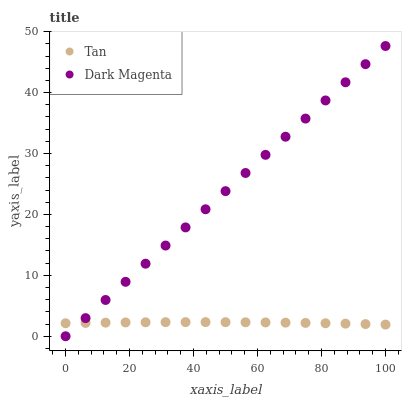Does Tan have the minimum area under the curve?
Answer yes or no. Yes. Does Dark Magenta have the maximum area under the curve?
Answer yes or no. Yes. Does Dark Magenta have the minimum area under the curve?
Answer yes or no. No. Is Dark Magenta the smoothest?
Answer yes or no. Yes. Is Tan the roughest?
Answer yes or no. Yes. Is Dark Magenta the roughest?
Answer yes or no. No. Does Dark Magenta have the lowest value?
Answer yes or no. Yes. Does Dark Magenta have the highest value?
Answer yes or no. Yes. Does Tan intersect Dark Magenta?
Answer yes or no. Yes. Is Tan less than Dark Magenta?
Answer yes or no. No. Is Tan greater than Dark Magenta?
Answer yes or no. No. 